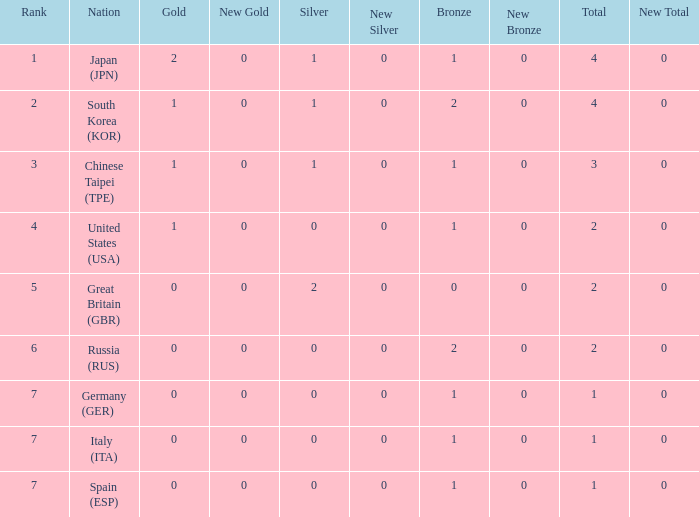Would you be able to parse every entry in this table? {'header': ['Rank', 'Nation', 'Gold', 'New Gold', 'Silver', 'New Silver', 'Bronze', 'New Bronze', 'Total', 'New Total'], 'rows': [['1', 'Japan (JPN)', '2', '0', '1', '0', '1', '0', '4', '0'], ['2', 'South Korea (KOR)', '1', '0', '1', '0', '2', '0', '4', '0'], ['3', 'Chinese Taipei (TPE)', '1', '0', '1', '0', '1', '0', '3', '0'], ['4', 'United States (USA)', '1', '0', '0', '0', '1', '0', '2', '0'], ['5', 'Great Britain (GBR)', '0', '0', '2', '0', '0', '0', '2', '0'], ['6', 'Russia (RUS)', '0', '0', '0', '0', '2', '0', '2', '0'], ['7', 'Germany (GER)', '0', '0', '0', '0', '1', '0', '1', '0'], ['7', 'Italy (ITA)', '0', '0', '0', '0', '1', '0', '1', '0'], ['7', 'Spain (ESP)', '0', '0', '0', '0', '1', '0', '1', '0']]} What is the rank of the country with more than 2 medals, and 2 gold medals? 1.0. 